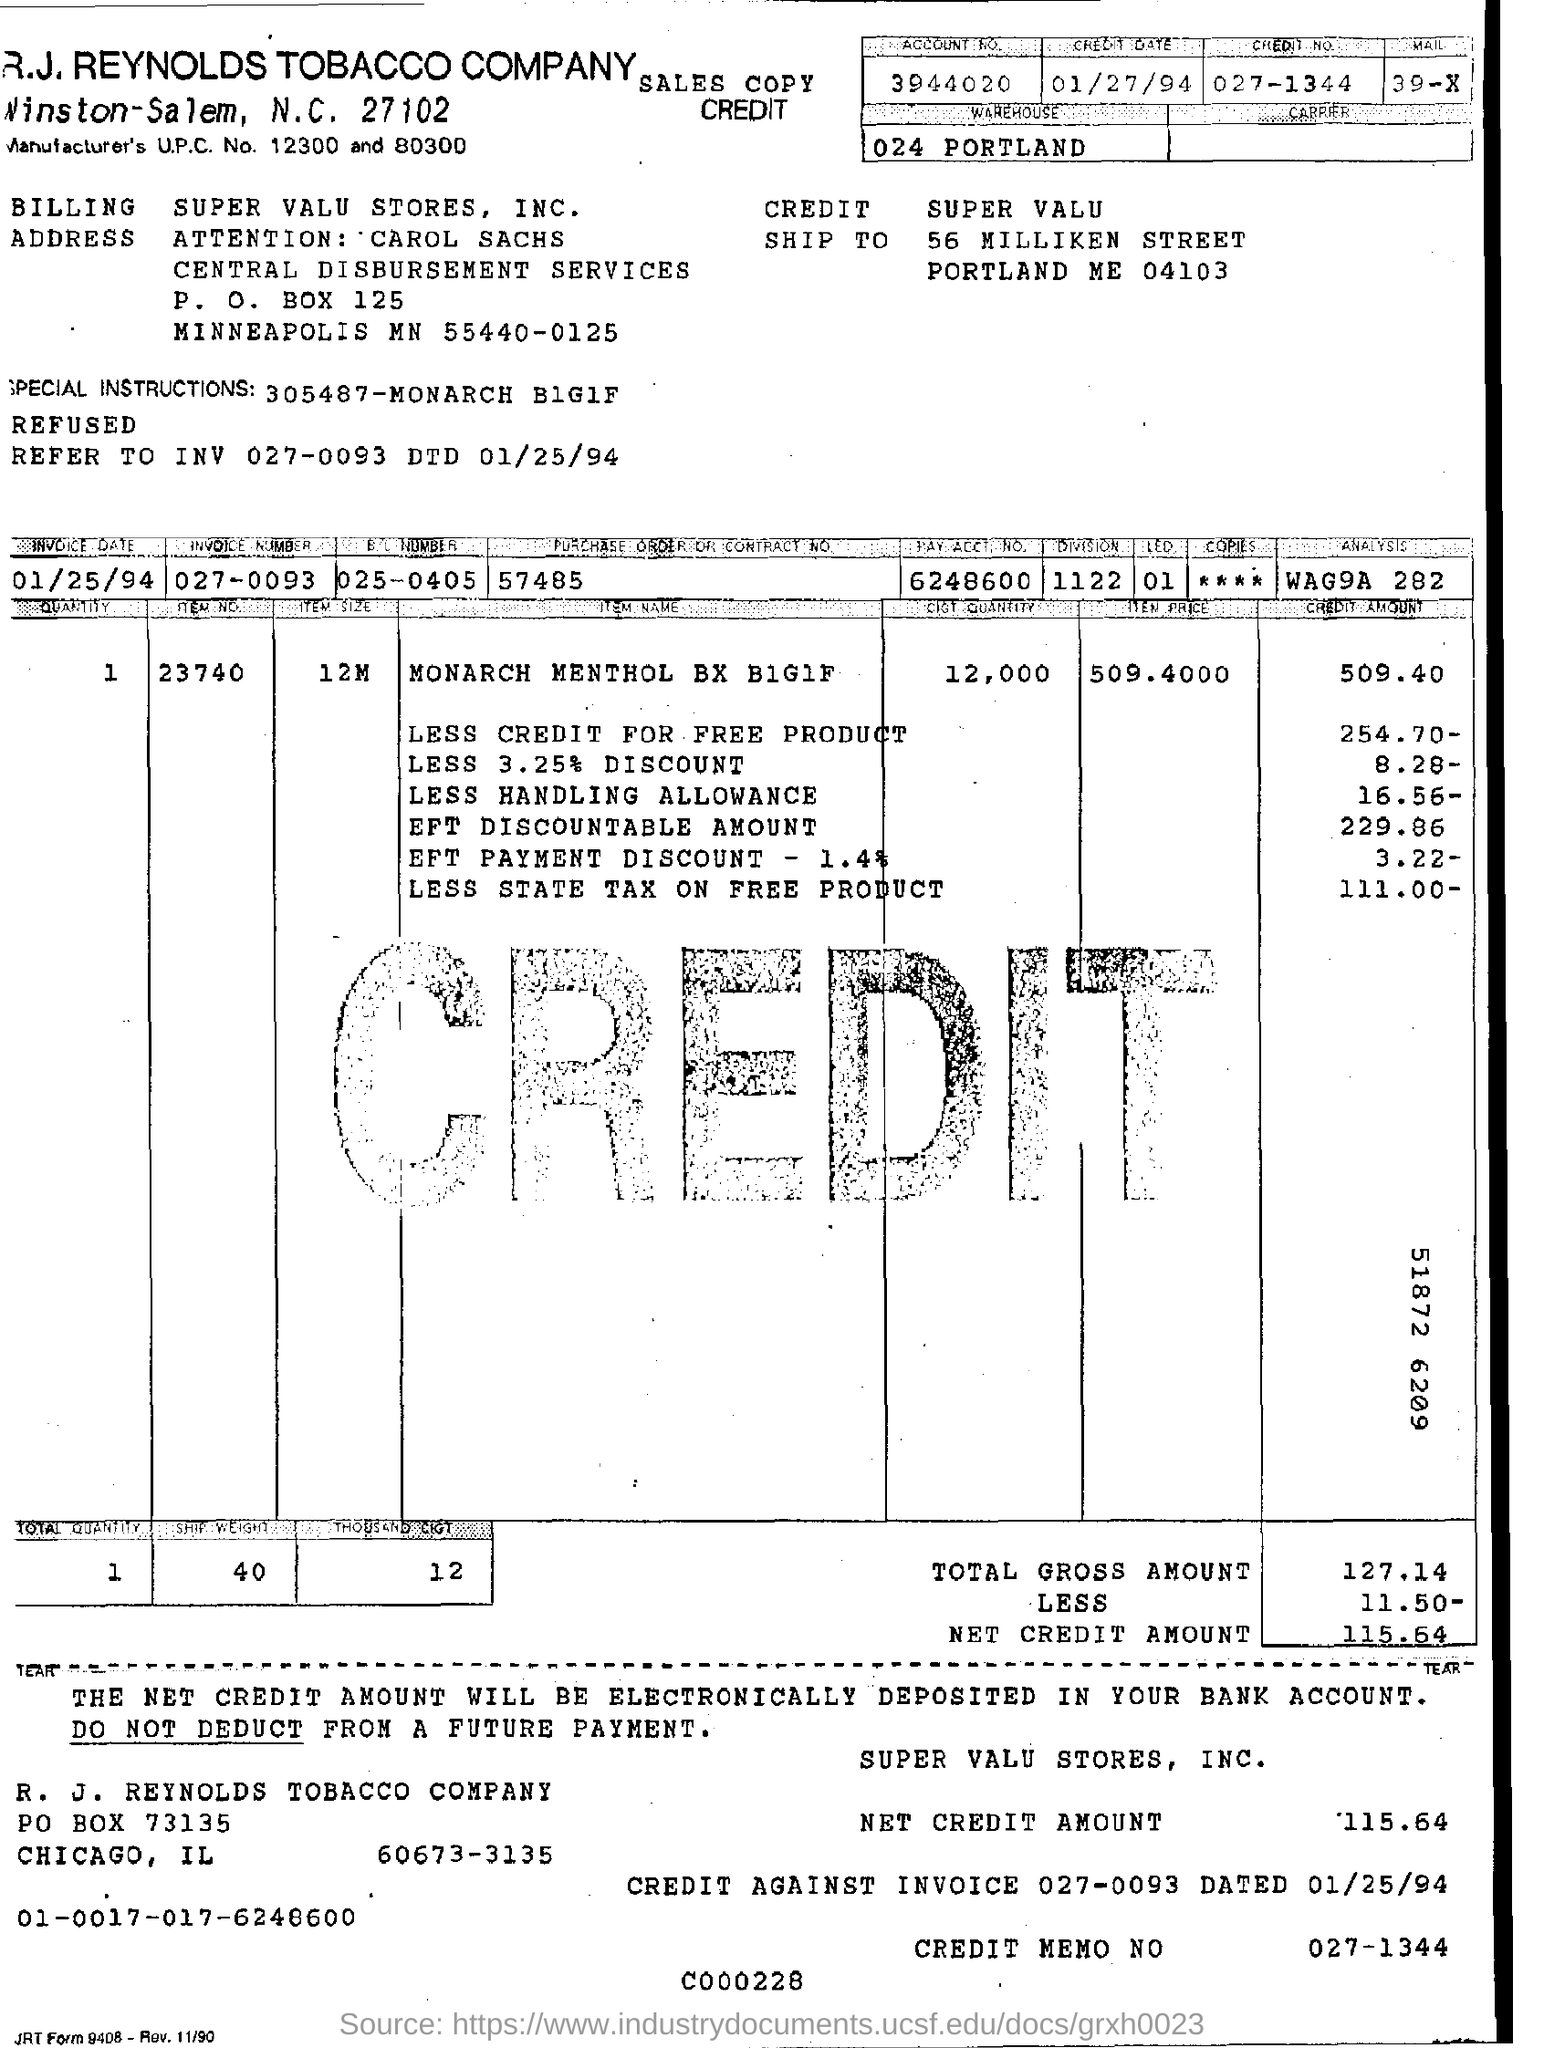R.J.REYNOLDS TOBACCO COMPANY billing to which company?
Provide a succinct answer. SUPER VALU STORES, INC. How much credit amount for the less handling allowance?
Offer a very short reply. 16.56. What is the date of invoice?
Ensure brevity in your answer.  01/25/94. 